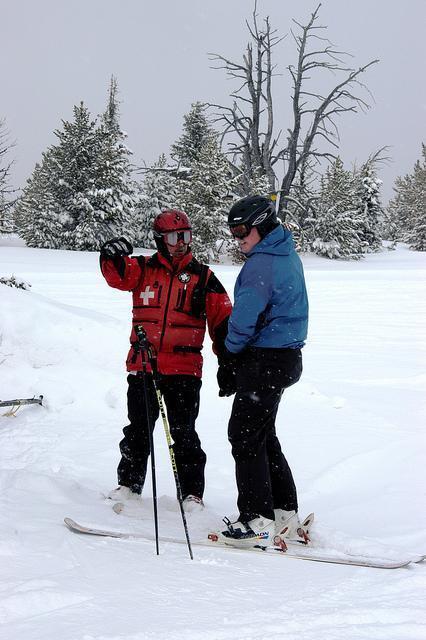What does the man in the red jacket's patch indicate?
Select the correct answer and articulate reasoning with the following format: 'Answer: answer
Rationale: rationale.'
Options: Emergency personnel, police, fire fighter, us military. Answer: emergency personnel.
Rationale: The white cross surrounded by red on this man's jacket indicate medical training. 